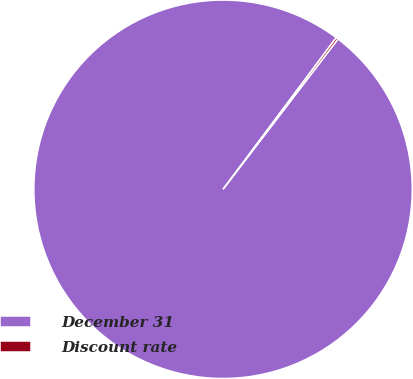Convert chart to OTSL. <chart><loc_0><loc_0><loc_500><loc_500><pie_chart><fcel>December 31<fcel>Discount rate<nl><fcel>99.81%<fcel>0.19%<nl></chart> 